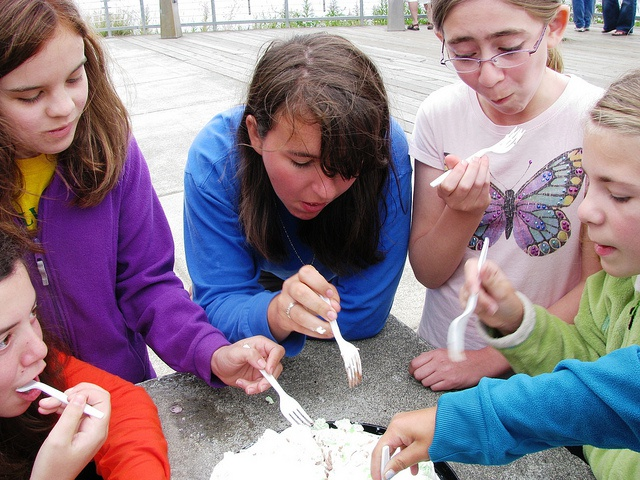Describe the objects in this image and their specific colors. I can see people in brown, purple, and lightpink tones, people in brown, black, blue, and gray tones, people in brown, lightgray, lightpink, and darkgray tones, people in brown, pink, olive, darkgray, and gray tones, and people in brown, lightpink, black, red, and lightgray tones in this image. 